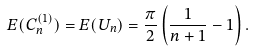Convert formula to latex. <formula><loc_0><loc_0><loc_500><loc_500>E ( C _ { n } ^ { ( 1 ) } ) = E ( U _ { n } ) = \frac { \pi } { 2 } \left ( \frac { 1 } { n + 1 } - 1 \right ) .</formula> 